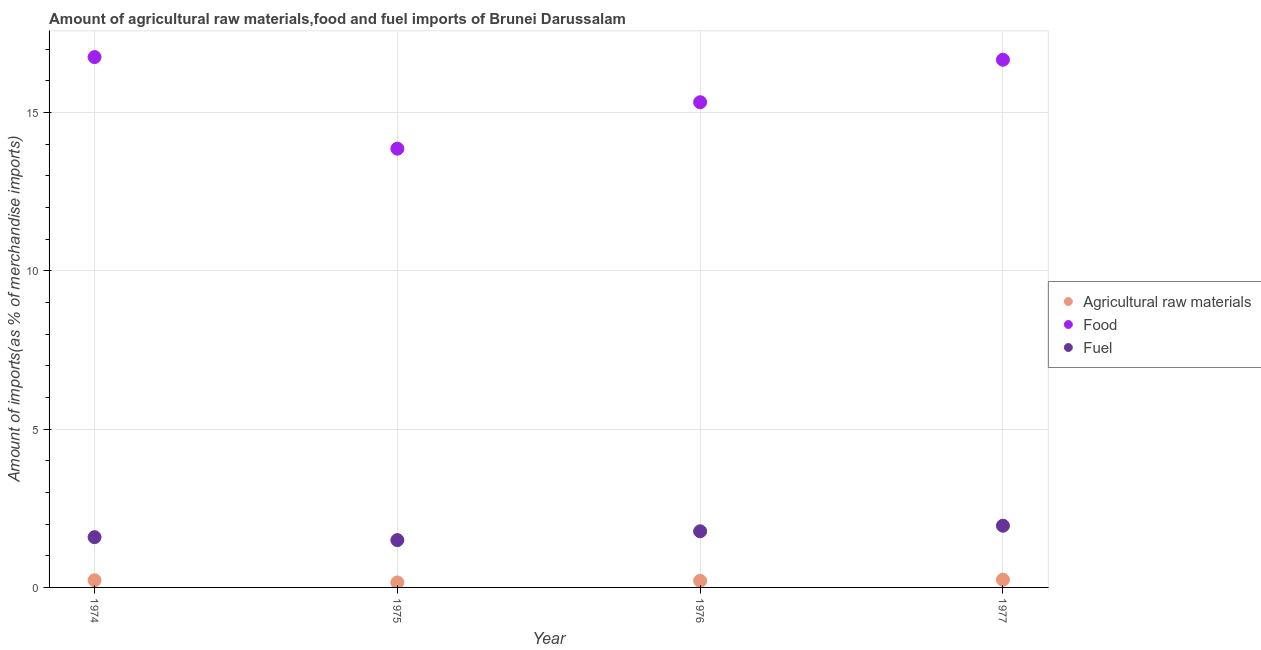How many different coloured dotlines are there?
Make the answer very short. 3. What is the percentage of food imports in 1977?
Offer a terse response. 16.67. Across all years, what is the maximum percentage of raw materials imports?
Your answer should be compact. 0.24. Across all years, what is the minimum percentage of food imports?
Offer a very short reply. 13.86. In which year was the percentage of fuel imports minimum?
Give a very brief answer. 1975. What is the total percentage of raw materials imports in the graph?
Provide a succinct answer. 0.84. What is the difference between the percentage of fuel imports in 1975 and that in 1977?
Ensure brevity in your answer.  -0.45. What is the difference between the percentage of raw materials imports in 1974 and the percentage of food imports in 1977?
Your answer should be very brief. -16.44. What is the average percentage of raw materials imports per year?
Your response must be concise. 0.21. In the year 1976, what is the difference between the percentage of fuel imports and percentage of raw materials imports?
Provide a succinct answer. 1.57. What is the ratio of the percentage of fuel imports in 1975 to that in 1976?
Provide a succinct answer. 0.84. Is the percentage of raw materials imports in 1975 less than that in 1976?
Your response must be concise. Yes. What is the difference between the highest and the second highest percentage of raw materials imports?
Provide a succinct answer. 0.02. What is the difference between the highest and the lowest percentage of fuel imports?
Provide a succinct answer. 0.45. In how many years, is the percentage of fuel imports greater than the average percentage of fuel imports taken over all years?
Your response must be concise. 2. Is it the case that in every year, the sum of the percentage of raw materials imports and percentage of food imports is greater than the percentage of fuel imports?
Offer a very short reply. Yes. What is the difference between two consecutive major ticks on the Y-axis?
Give a very brief answer. 5. Are the values on the major ticks of Y-axis written in scientific E-notation?
Offer a terse response. No. How many legend labels are there?
Your answer should be very brief. 3. What is the title of the graph?
Offer a very short reply. Amount of agricultural raw materials,food and fuel imports of Brunei Darussalam. Does "Tertiary education" appear as one of the legend labels in the graph?
Give a very brief answer. No. What is the label or title of the X-axis?
Keep it short and to the point. Year. What is the label or title of the Y-axis?
Ensure brevity in your answer.  Amount of imports(as % of merchandise imports). What is the Amount of imports(as % of merchandise imports) of Agricultural raw materials in 1974?
Your answer should be very brief. 0.23. What is the Amount of imports(as % of merchandise imports) in Food in 1974?
Keep it short and to the point. 16.75. What is the Amount of imports(as % of merchandise imports) of Fuel in 1974?
Offer a terse response. 1.59. What is the Amount of imports(as % of merchandise imports) of Agricultural raw materials in 1975?
Provide a short and direct response. 0.16. What is the Amount of imports(as % of merchandise imports) of Food in 1975?
Give a very brief answer. 13.86. What is the Amount of imports(as % of merchandise imports) in Fuel in 1975?
Keep it short and to the point. 1.49. What is the Amount of imports(as % of merchandise imports) of Agricultural raw materials in 1976?
Your response must be concise. 0.21. What is the Amount of imports(as % of merchandise imports) in Food in 1976?
Ensure brevity in your answer.  15.33. What is the Amount of imports(as % of merchandise imports) in Fuel in 1976?
Offer a terse response. 1.77. What is the Amount of imports(as % of merchandise imports) in Agricultural raw materials in 1977?
Provide a short and direct response. 0.24. What is the Amount of imports(as % of merchandise imports) of Food in 1977?
Offer a very short reply. 16.67. What is the Amount of imports(as % of merchandise imports) in Fuel in 1977?
Your response must be concise. 1.95. Across all years, what is the maximum Amount of imports(as % of merchandise imports) of Agricultural raw materials?
Your answer should be compact. 0.24. Across all years, what is the maximum Amount of imports(as % of merchandise imports) of Food?
Give a very brief answer. 16.75. Across all years, what is the maximum Amount of imports(as % of merchandise imports) of Fuel?
Your response must be concise. 1.95. Across all years, what is the minimum Amount of imports(as % of merchandise imports) of Agricultural raw materials?
Your answer should be very brief. 0.16. Across all years, what is the minimum Amount of imports(as % of merchandise imports) of Food?
Offer a very short reply. 13.86. Across all years, what is the minimum Amount of imports(as % of merchandise imports) in Fuel?
Provide a short and direct response. 1.49. What is the total Amount of imports(as % of merchandise imports) of Agricultural raw materials in the graph?
Offer a very short reply. 0.84. What is the total Amount of imports(as % of merchandise imports) of Food in the graph?
Keep it short and to the point. 62.61. What is the total Amount of imports(as % of merchandise imports) in Fuel in the graph?
Your response must be concise. 6.81. What is the difference between the Amount of imports(as % of merchandise imports) in Agricultural raw materials in 1974 and that in 1975?
Offer a terse response. 0.07. What is the difference between the Amount of imports(as % of merchandise imports) in Food in 1974 and that in 1975?
Provide a succinct answer. 2.89. What is the difference between the Amount of imports(as % of merchandise imports) of Fuel in 1974 and that in 1975?
Make the answer very short. 0.09. What is the difference between the Amount of imports(as % of merchandise imports) in Agricultural raw materials in 1974 and that in 1976?
Your answer should be very brief. 0.02. What is the difference between the Amount of imports(as % of merchandise imports) of Food in 1974 and that in 1976?
Give a very brief answer. 1.43. What is the difference between the Amount of imports(as % of merchandise imports) in Fuel in 1974 and that in 1976?
Give a very brief answer. -0.19. What is the difference between the Amount of imports(as % of merchandise imports) of Agricultural raw materials in 1974 and that in 1977?
Your answer should be very brief. -0.02. What is the difference between the Amount of imports(as % of merchandise imports) of Food in 1974 and that in 1977?
Your answer should be compact. 0.08. What is the difference between the Amount of imports(as % of merchandise imports) of Fuel in 1974 and that in 1977?
Make the answer very short. -0.36. What is the difference between the Amount of imports(as % of merchandise imports) in Agricultural raw materials in 1975 and that in 1976?
Give a very brief answer. -0.05. What is the difference between the Amount of imports(as % of merchandise imports) of Food in 1975 and that in 1976?
Offer a terse response. -1.47. What is the difference between the Amount of imports(as % of merchandise imports) of Fuel in 1975 and that in 1976?
Ensure brevity in your answer.  -0.28. What is the difference between the Amount of imports(as % of merchandise imports) of Agricultural raw materials in 1975 and that in 1977?
Give a very brief answer. -0.09. What is the difference between the Amount of imports(as % of merchandise imports) of Food in 1975 and that in 1977?
Provide a short and direct response. -2.81. What is the difference between the Amount of imports(as % of merchandise imports) of Fuel in 1975 and that in 1977?
Your response must be concise. -0.45. What is the difference between the Amount of imports(as % of merchandise imports) of Agricultural raw materials in 1976 and that in 1977?
Your answer should be very brief. -0.04. What is the difference between the Amount of imports(as % of merchandise imports) in Food in 1976 and that in 1977?
Your response must be concise. -1.34. What is the difference between the Amount of imports(as % of merchandise imports) of Fuel in 1976 and that in 1977?
Provide a short and direct response. -0.18. What is the difference between the Amount of imports(as % of merchandise imports) in Agricultural raw materials in 1974 and the Amount of imports(as % of merchandise imports) in Food in 1975?
Your answer should be very brief. -13.63. What is the difference between the Amount of imports(as % of merchandise imports) of Agricultural raw materials in 1974 and the Amount of imports(as % of merchandise imports) of Fuel in 1975?
Provide a short and direct response. -1.27. What is the difference between the Amount of imports(as % of merchandise imports) in Food in 1974 and the Amount of imports(as % of merchandise imports) in Fuel in 1975?
Provide a succinct answer. 15.26. What is the difference between the Amount of imports(as % of merchandise imports) of Agricultural raw materials in 1974 and the Amount of imports(as % of merchandise imports) of Food in 1976?
Keep it short and to the point. -15.1. What is the difference between the Amount of imports(as % of merchandise imports) in Agricultural raw materials in 1974 and the Amount of imports(as % of merchandise imports) in Fuel in 1976?
Provide a succinct answer. -1.55. What is the difference between the Amount of imports(as % of merchandise imports) of Food in 1974 and the Amount of imports(as % of merchandise imports) of Fuel in 1976?
Make the answer very short. 14.98. What is the difference between the Amount of imports(as % of merchandise imports) of Agricultural raw materials in 1974 and the Amount of imports(as % of merchandise imports) of Food in 1977?
Your response must be concise. -16.44. What is the difference between the Amount of imports(as % of merchandise imports) of Agricultural raw materials in 1974 and the Amount of imports(as % of merchandise imports) of Fuel in 1977?
Make the answer very short. -1.72. What is the difference between the Amount of imports(as % of merchandise imports) of Food in 1974 and the Amount of imports(as % of merchandise imports) of Fuel in 1977?
Make the answer very short. 14.8. What is the difference between the Amount of imports(as % of merchandise imports) of Agricultural raw materials in 1975 and the Amount of imports(as % of merchandise imports) of Food in 1976?
Offer a terse response. -15.17. What is the difference between the Amount of imports(as % of merchandise imports) in Agricultural raw materials in 1975 and the Amount of imports(as % of merchandise imports) in Fuel in 1976?
Provide a succinct answer. -1.62. What is the difference between the Amount of imports(as % of merchandise imports) of Food in 1975 and the Amount of imports(as % of merchandise imports) of Fuel in 1976?
Your answer should be very brief. 12.09. What is the difference between the Amount of imports(as % of merchandise imports) of Agricultural raw materials in 1975 and the Amount of imports(as % of merchandise imports) of Food in 1977?
Provide a succinct answer. -16.51. What is the difference between the Amount of imports(as % of merchandise imports) in Agricultural raw materials in 1975 and the Amount of imports(as % of merchandise imports) in Fuel in 1977?
Ensure brevity in your answer.  -1.79. What is the difference between the Amount of imports(as % of merchandise imports) in Food in 1975 and the Amount of imports(as % of merchandise imports) in Fuel in 1977?
Make the answer very short. 11.91. What is the difference between the Amount of imports(as % of merchandise imports) of Agricultural raw materials in 1976 and the Amount of imports(as % of merchandise imports) of Food in 1977?
Your answer should be compact. -16.46. What is the difference between the Amount of imports(as % of merchandise imports) in Agricultural raw materials in 1976 and the Amount of imports(as % of merchandise imports) in Fuel in 1977?
Keep it short and to the point. -1.74. What is the difference between the Amount of imports(as % of merchandise imports) in Food in 1976 and the Amount of imports(as % of merchandise imports) in Fuel in 1977?
Provide a short and direct response. 13.38. What is the average Amount of imports(as % of merchandise imports) of Agricultural raw materials per year?
Provide a short and direct response. 0.21. What is the average Amount of imports(as % of merchandise imports) of Food per year?
Keep it short and to the point. 15.65. What is the average Amount of imports(as % of merchandise imports) in Fuel per year?
Keep it short and to the point. 1.7. In the year 1974, what is the difference between the Amount of imports(as % of merchandise imports) of Agricultural raw materials and Amount of imports(as % of merchandise imports) of Food?
Your answer should be compact. -16.53. In the year 1974, what is the difference between the Amount of imports(as % of merchandise imports) of Agricultural raw materials and Amount of imports(as % of merchandise imports) of Fuel?
Keep it short and to the point. -1.36. In the year 1974, what is the difference between the Amount of imports(as % of merchandise imports) in Food and Amount of imports(as % of merchandise imports) in Fuel?
Your answer should be compact. 15.17. In the year 1975, what is the difference between the Amount of imports(as % of merchandise imports) of Agricultural raw materials and Amount of imports(as % of merchandise imports) of Food?
Offer a terse response. -13.7. In the year 1975, what is the difference between the Amount of imports(as % of merchandise imports) in Agricultural raw materials and Amount of imports(as % of merchandise imports) in Fuel?
Provide a short and direct response. -1.34. In the year 1975, what is the difference between the Amount of imports(as % of merchandise imports) in Food and Amount of imports(as % of merchandise imports) in Fuel?
Keep it short and to the point. 12.37. In the year 1976, what is the difference between the Amount of imports(as % of merchandise imports) in Agricultural raw materials and Amount of imports(as % of merchandise imports) in Food?
Your answer should be very brief. -15.12. In the year 1976, what is the difference between the Amount of imports(as % of merchandise imports) of Agricultural raw materials and Amount of imports(as % of merchandise imports) of Fuel?
Make the answer very short. -1.57. In the year 1976, what is the difference between the Amount of imports(as % of merchandise imports) in Food and Amount of imports(as % of merchandise imports) in Fuel?
Your response must be concise. 13.55. In the year 1977, what is the difference between the Amount of imports(as % of merchandise imports) in Agricultural raw materials and Amount of imports(as % of merchandise imports) in Food?
Offer a very short reply. -16.43. In the year 1977, what is the difference between the Amount of imports(as % of merchandise imports) in Agricultural raw materials and Amount of imports(as % of merchandise imports) in Fuel?
Your answer should be compact. -1.71. In the year 1977, what is the difference between the Amount of imports(as % of merchandise imports) in Food and Amount of imports(as % of merchandise imports) in Fuel?
Offer a terse response. 14.72. What is the ratio of the Amount of imports(as % of merchandise imports) in Agricultural raw materials in 1974 to that in 1975?
Ensure brevity in your answer.  1.45. What is the ratio of the Amount of imports(as % of merchandise imports) in Food in 1974 to that in 1975?
Provide a short and direct response. 1.21. What is the ratio of the Amount of imports(as % of merchandise imports) of Fuel in 1974 to that in 1975?
Provide a short and direct response. 1.06. What is the ratio of the Amount of imports(as % of merchandise imports) in Agricultural raw materials in 1974 to that in 1976?
Ensure brevity in your answer.  1.1. What is the ratio of the Amount of imports(as % of merchandise imports) in Food in 1974 to that in 1976?
Ensure brevity in your answer.  1.09. What is the ratio of the Amount of imports(as % of merchandise imports) in Fuel in 1974 to that in 1976?
Ensure brevity in your answer.  0.9. What is the ratio of the Amount of imports(as % of merchandise imports) of Agricultural raw materials in 1974 to that in 1977?
Give a very brief answer. 0.93. What is the ratio of the Amount of imports(as % of merchandise imports) in Food in 1974 to that in 1977?
Your answer should be compact. 1. What is the ratio of the Amount of imports(as % of merchandise imports) in Fuel in 1974 to that in 1977?
Provide a short and direct response. 0.81. What is the ratio of the Amount of imports(as % of merchandise imports) of Agricultural raw materials in 1975 to that in 1976?
Your answer should be very brief. 0.76. What is the ratio of the Amount of imports(as % of merchandise imports) in Food in 1975 to that in 1976?
Provide a short and direct response. 0.9. What is the ratio of the Amount of imports(as % of merchandise imports) in Fuel in 1975 to that in 1976?
Provide a short and direct response. 0.84. What is the ratio of the Amount of imports(as % of merchandise imports) in Agricultural raw materials in 1975 to that in 1977?
Keep it short and to the point. 0.64. What is the ratio of the Amount of imports(as % of merchandise imports) of Food in 1975 to that in 1977?
Provide a succinct answer. 0.83. What is the ratio of the Amount of imports(as % of merchandise imports) of Fuel in 1975 to that in 1977?
Your response must be concise. 0.77. What is the ratio of the Amount of imports(as % of merchandise imports) of Agricultural raw materials in 1976 to that in 1977?
Give a very brief answer. 0.85. What is the ratio of the Amount of imports(as % of merchandise imports) in Food in 1976 to that in 1977?
Your response must be concise. 0.92. What is the ratio of the Amount of imports(as % of merchandise imports) in Fuel in 1976 to that in 1977?
Keep it short and to the point. 0.91. What is the difference between the highest and the second highest Amount of imports(as % of merchandise imports) in Agricultural raw materials?
Make the answer very short. 0.02. What is the difference between the highest and the second highest Amount of imports(as % of merchandise imports) of Food?
Your answer should be compact. 0.08. What is the difference between the highest and the second highest Amount of imports(as % of merchandise imports) in Fuel?
Offer a terse response. 0.18. What is the difference between the highest and the lowest Amount of imports(as % of merchandise imports) in Agricultural raw materials?
Give a very brief answer. 0.09. What is the difference between the highest and the lowest Amount of imports(as % of merchandise imports) in Food?
Provide a short and direct response. 2.89. What is the difference between the highest and the lowest Amount of imports(as % of merchandise imports) in Fuel?
Offer a terse response. 0.45. 